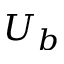<formula> <loc_0><loc_0><loc_500><loc_500>U _ { b }</formula> 